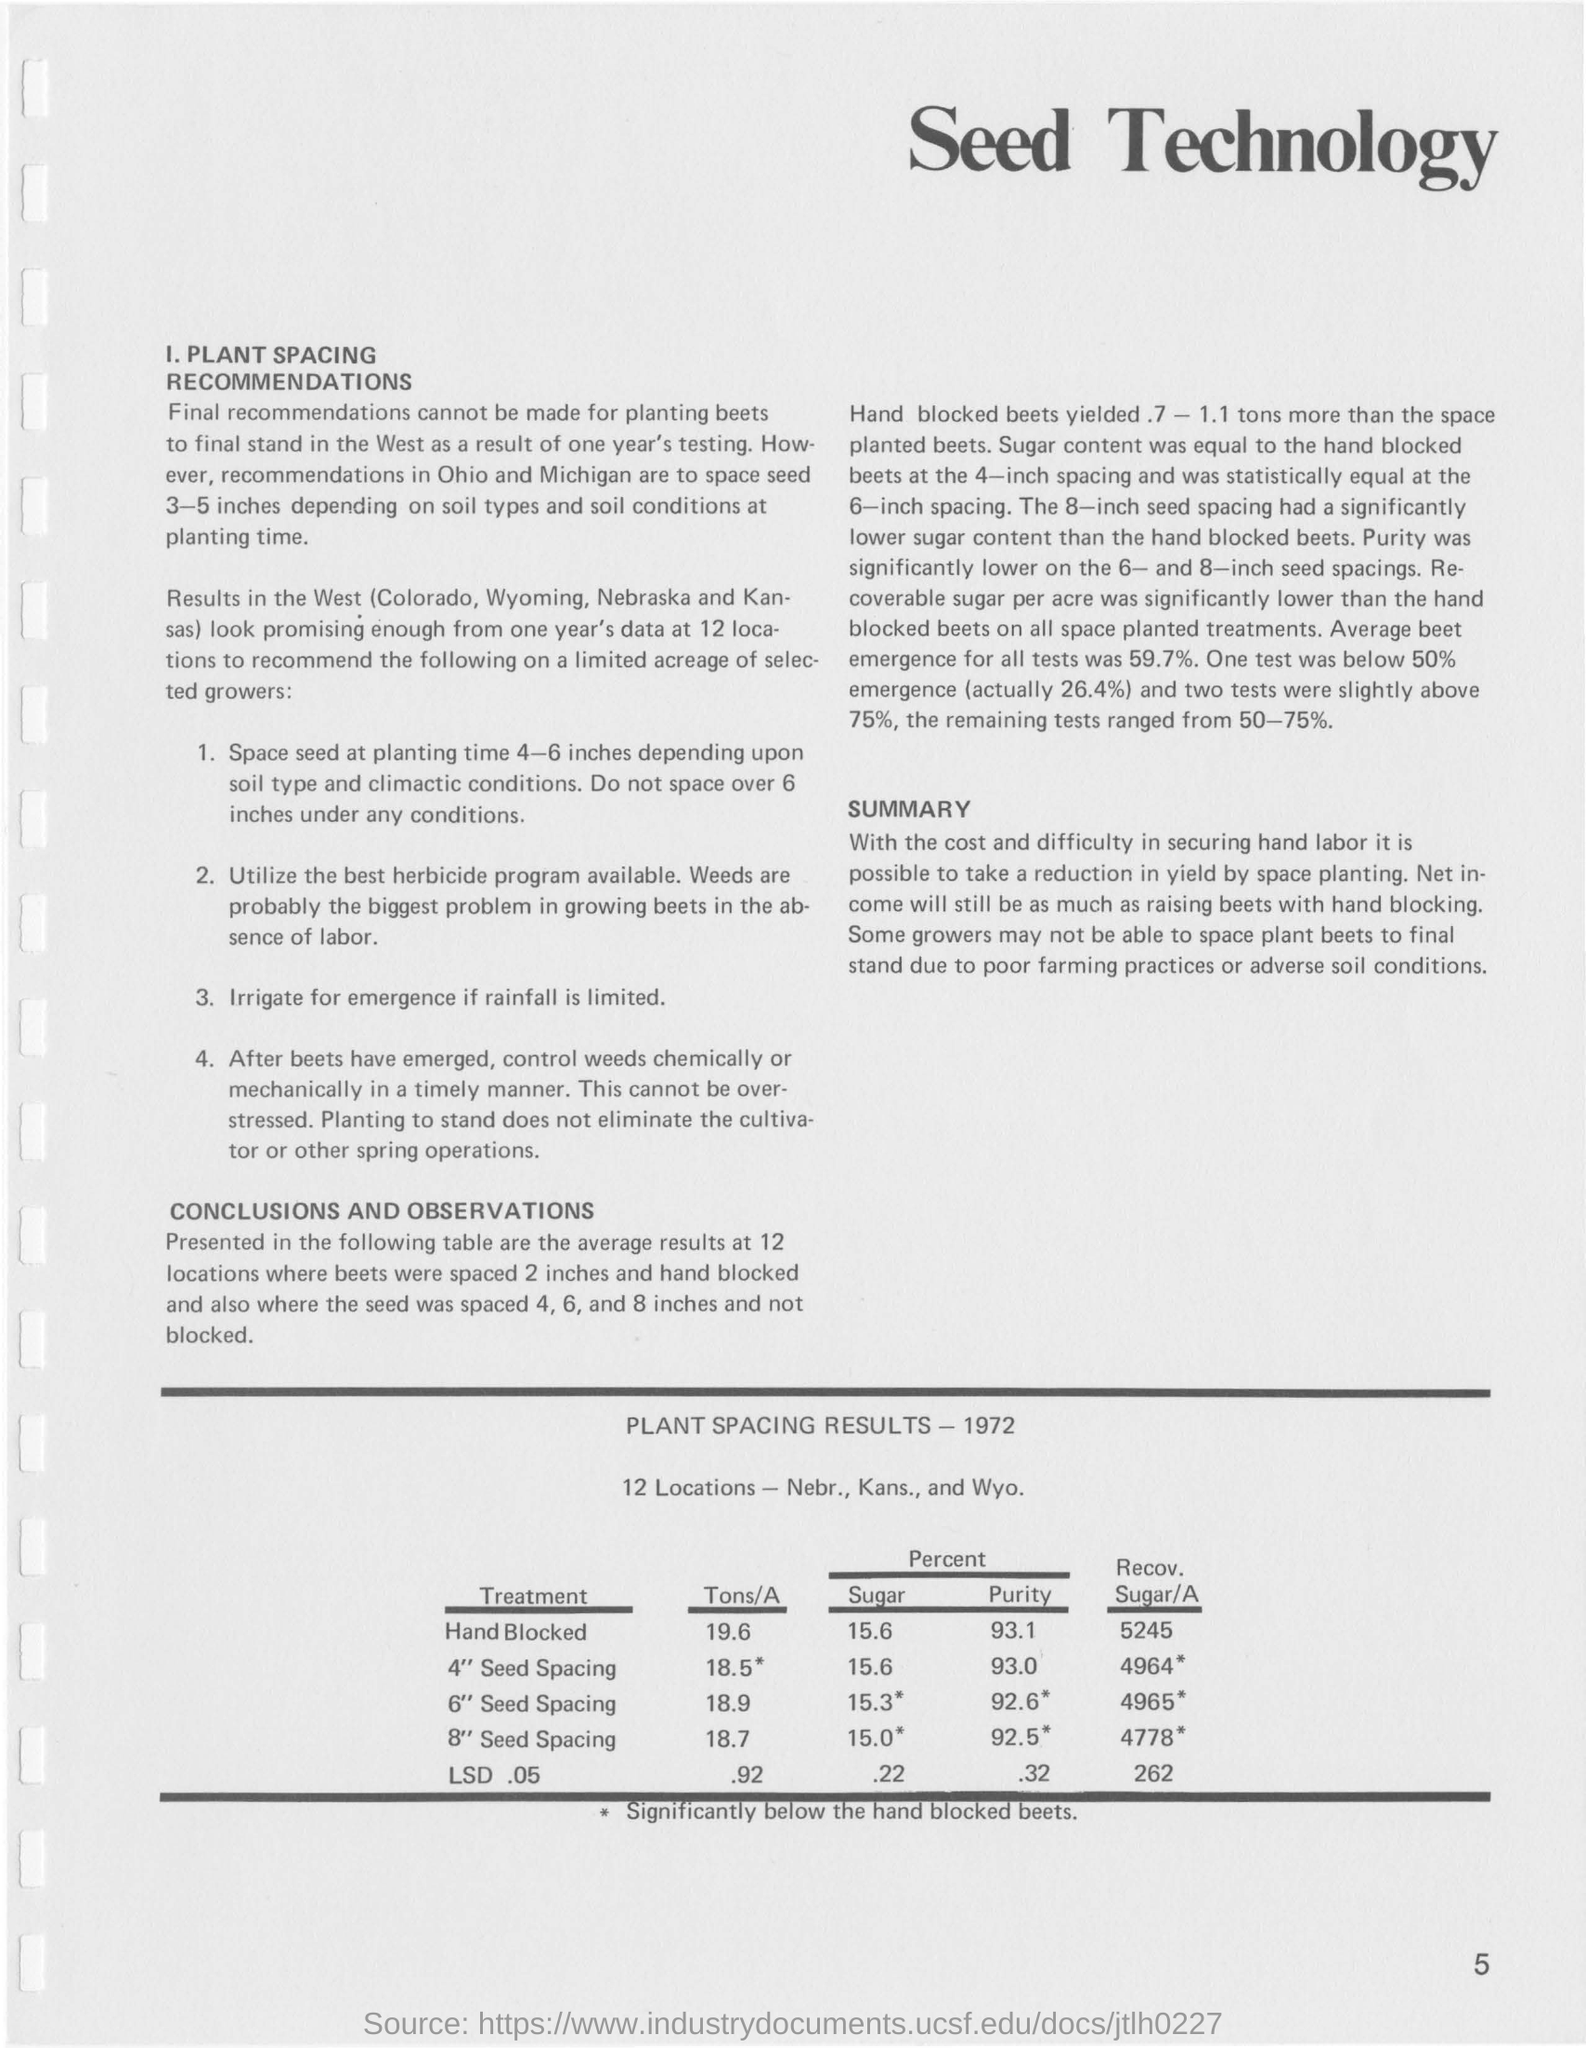Name the places included in west where results are seen.
Your response must be concise. Colorado, wyoming, nebraska and kansas. 